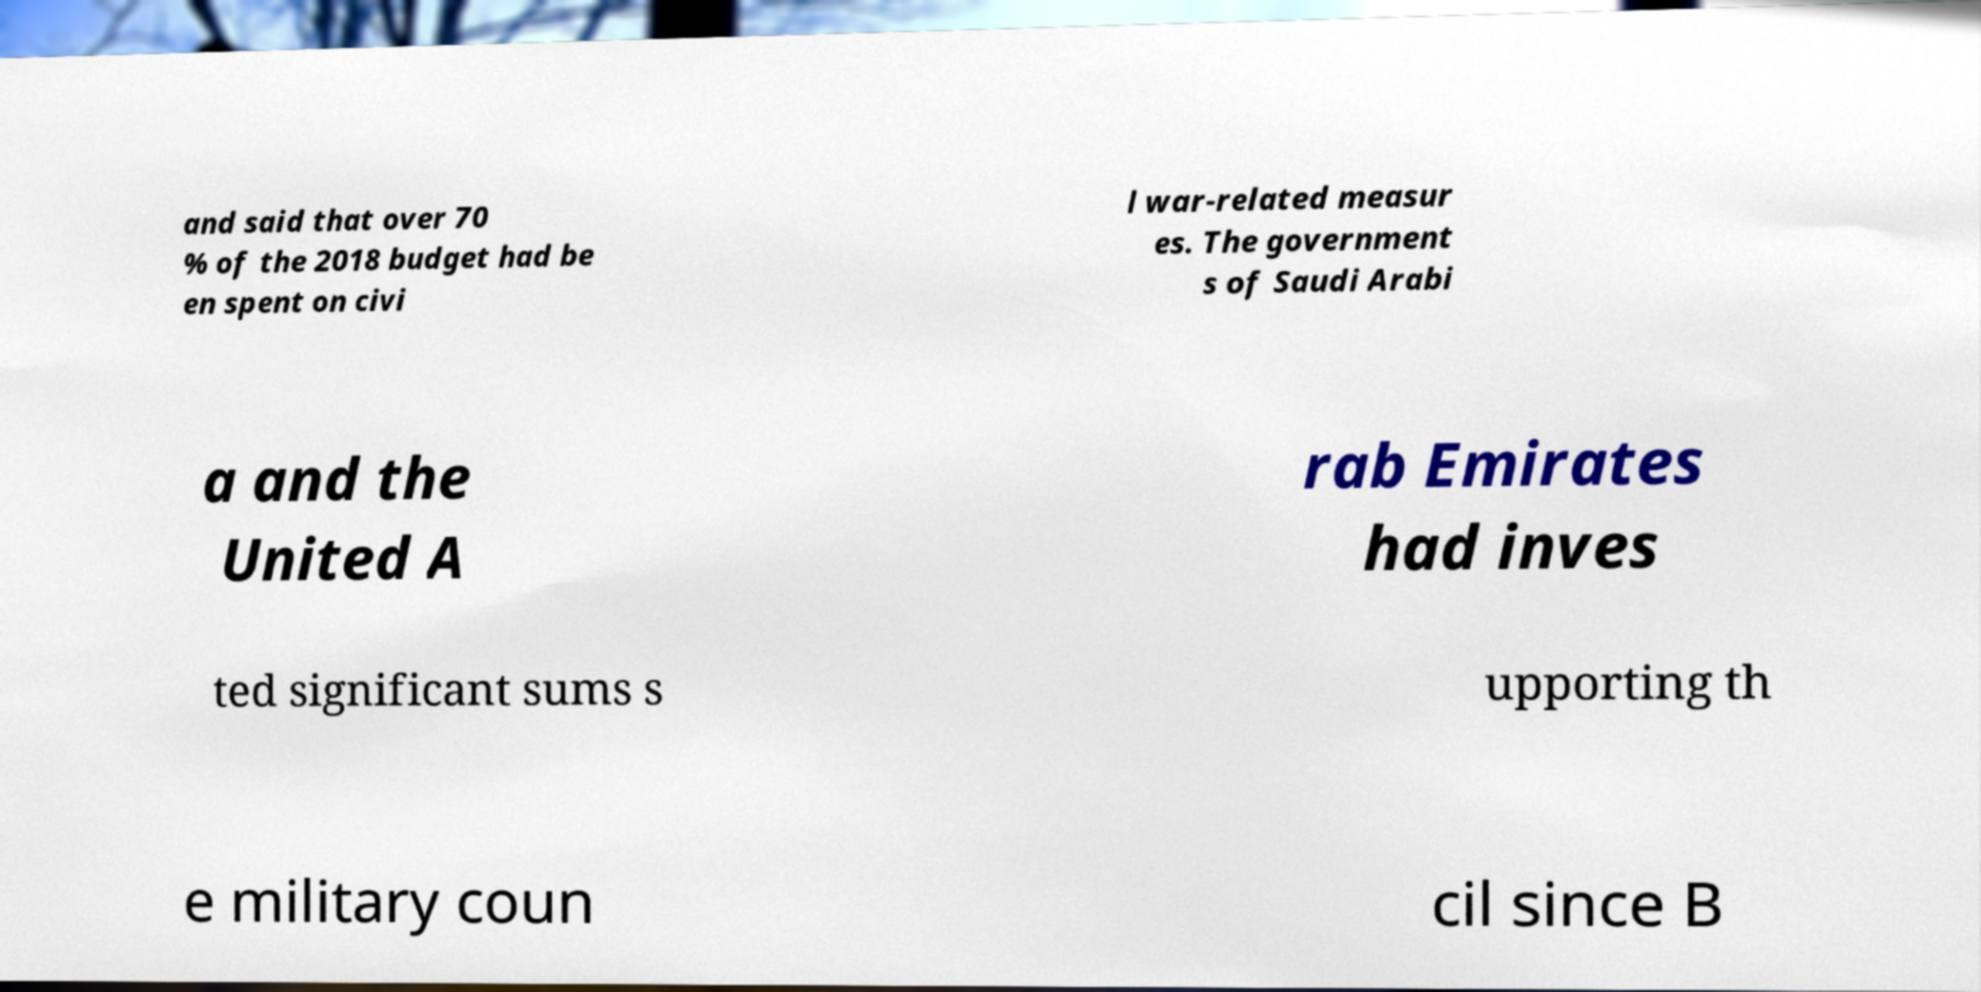Can you accurately transcribe the text from the provided image for me? and said that over 70 % of the 2018 budget had be en spent on civi l war-related measur es. The government s of Saudi Arabi a and the United A rab Emirates had inves ted significant sums s upporting th e military coun cil since B 